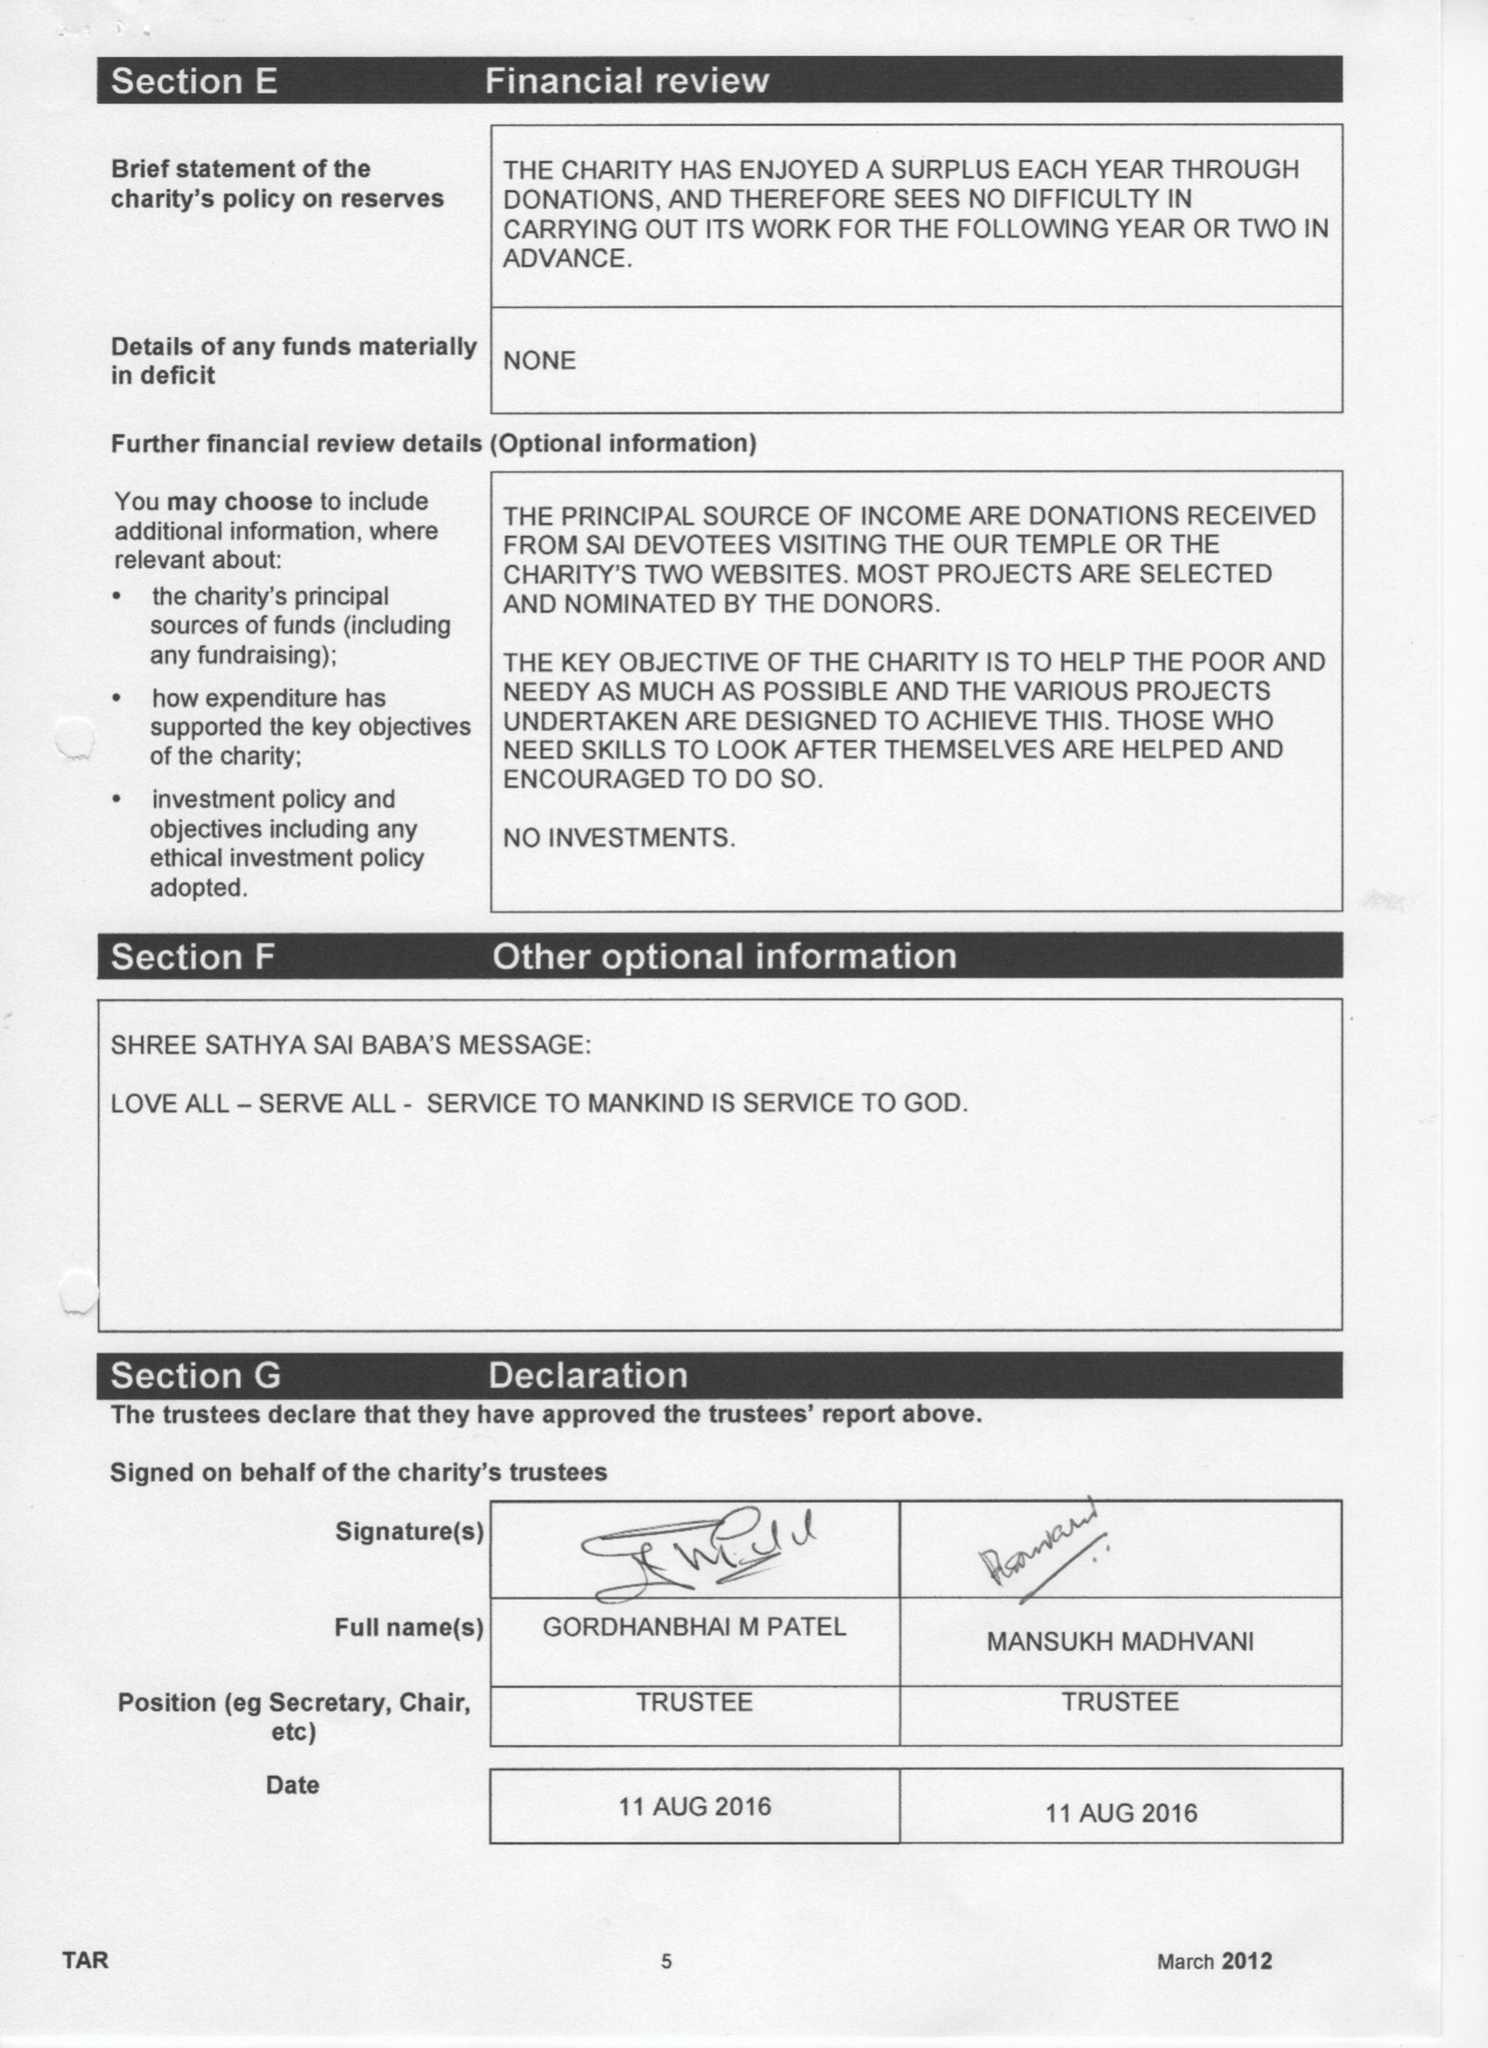What is the value for the charity_name?
Answer the question using a single word or phrase. Sai Sruti Charitable Trust 